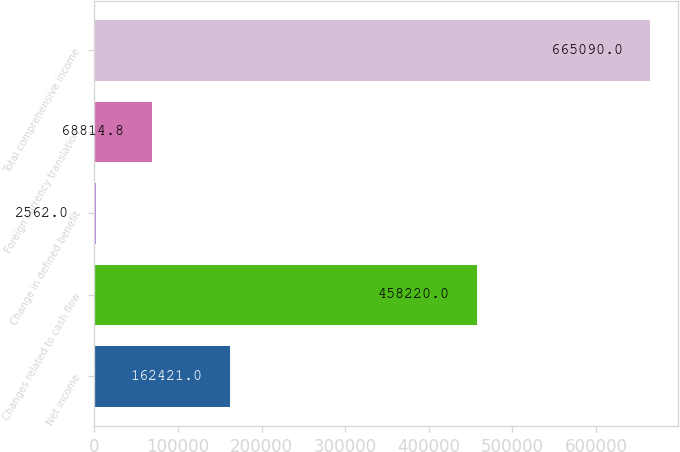Convert chart. <chart><loc_0><loc_0><loc_500><loc_500><bar_chart><fcel>Net income<fcel>Changes related to cash flow<fcel>Change in defined benefit<fcel>Foreign currency translation<fcel>Total comprehensive income<nl><fcel>162421<fcel>458220<fcel>2562<fcel>68814.8<fcel>665090<nl></chart> 